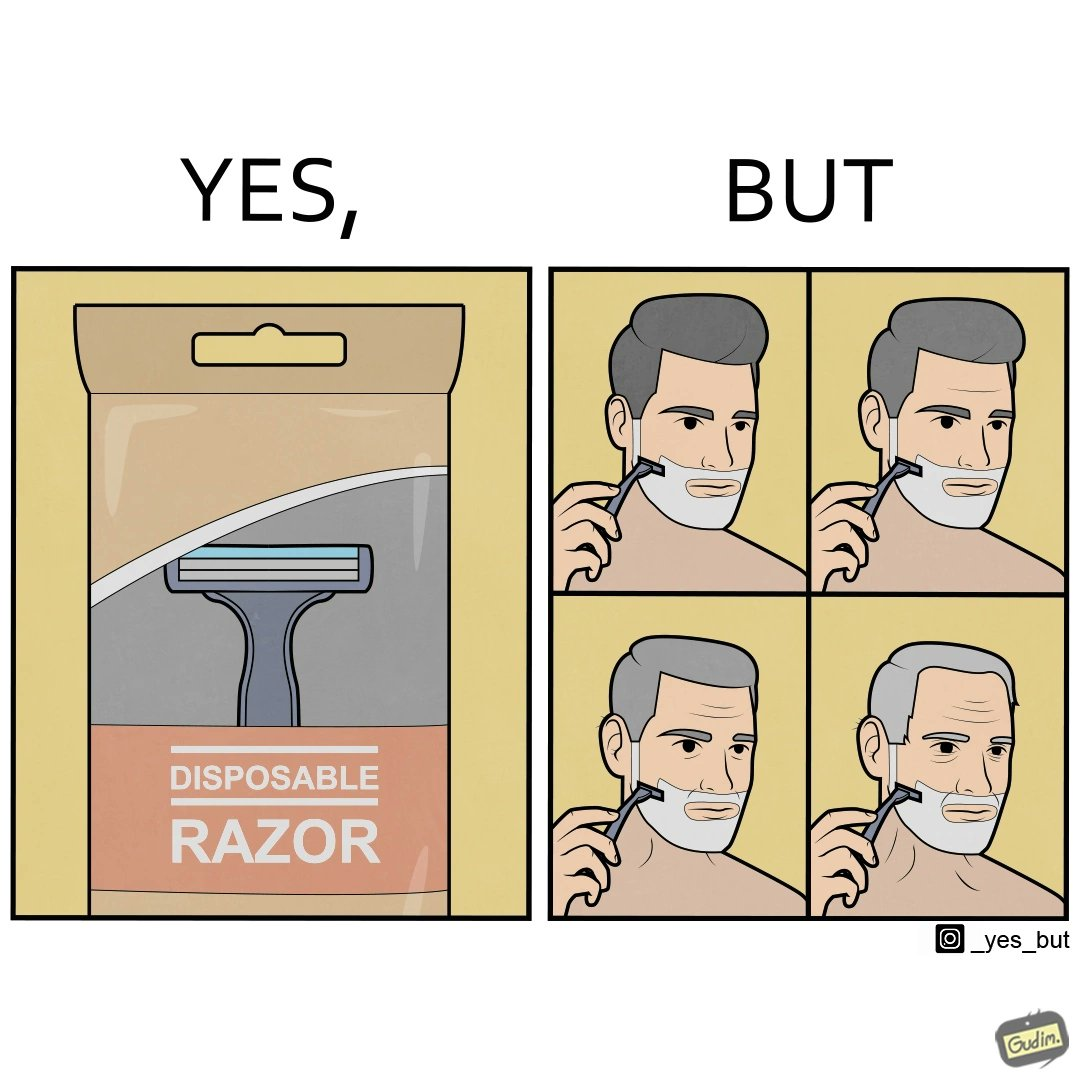What makes this image funny or satirical? The images are funny since the show people end up using disposable razors for so long that they need not dispose it anymore. 